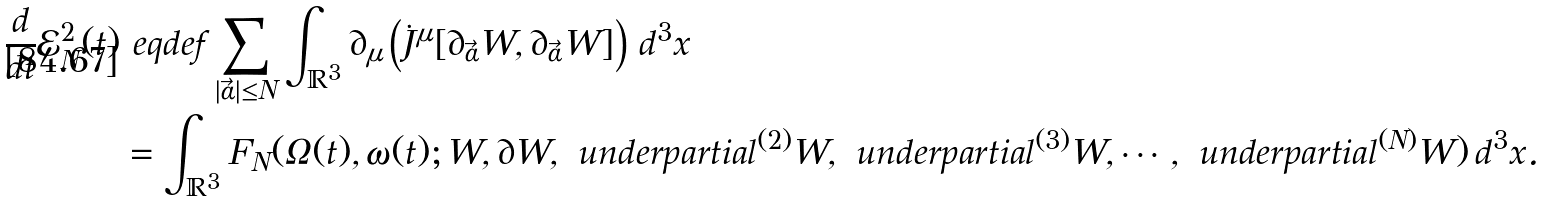Convert formula to latex. <formula><loc_0><loc_0><loc_500><loc_500>\frac { d } { d t } \mathcal { E } _ { N } ^ { 2 } ( t ) & \ e q d e f \sum _ { | \vec { \alpha } | \leq N } \int _ { \mathbb { R } ^ { 3 } } \partial _ { \mu } \left ( \dot { J } ^ { \mu } [ \partial _ { \vec { \alpha } } W , \partial _ { \vec { \alpha } } W ] \right ) \, d ^ { 3 } x \\ & = \int _ { \mathbb { R } ^ { 3 } } F _ { N } ( \Omega ( t ) , \omega ( t ) ; W , \partial W , \ u n d e r p a r t i a l ^ { ( 2 ) } W , \ u n d e r p a r t i a l ^ { ( 3 ) } W , \cdots , \ u n d e r p a r t i a l ^ { ( N ) } W ) \, d ^ { 3 } x .</formula> 